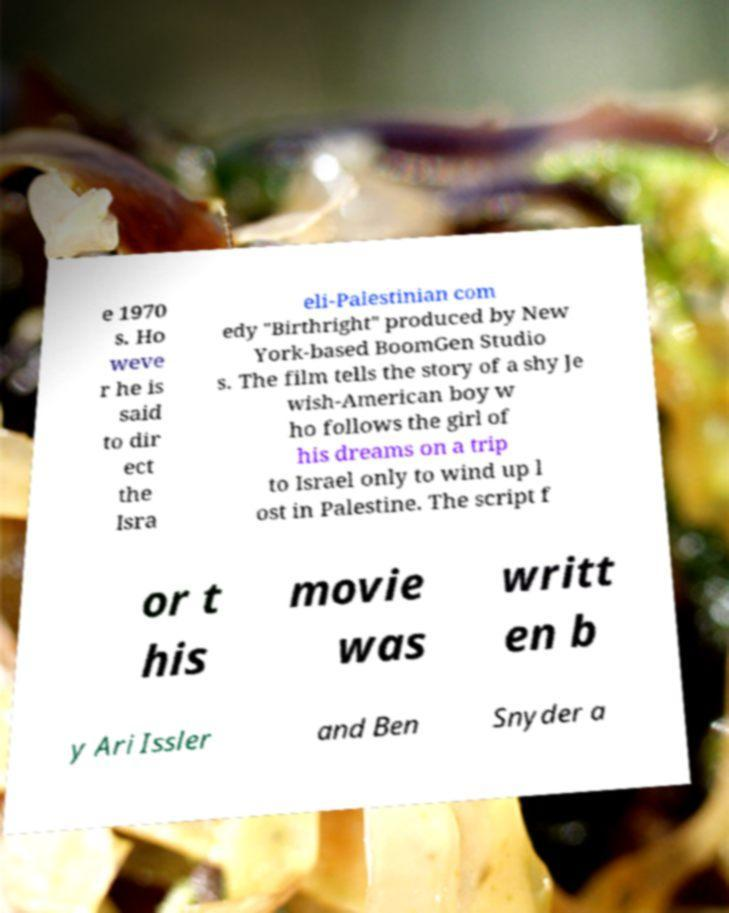What messages or text are displayed in this image? I need them in a readable, typed format. e 1970 s. Ho weve r he is said to dir ect the Isra eli-Palestinian com edy "Birthright" produced by New York-based BoomGen Studio s. The film tells the story of a shy Je wish-American boy w ho follows the girl of his dreams on a trip to Israel only to wind up l ost in Palestine. The script f or t his movie was writt en b y Ari Issler and Ben Snyder a 